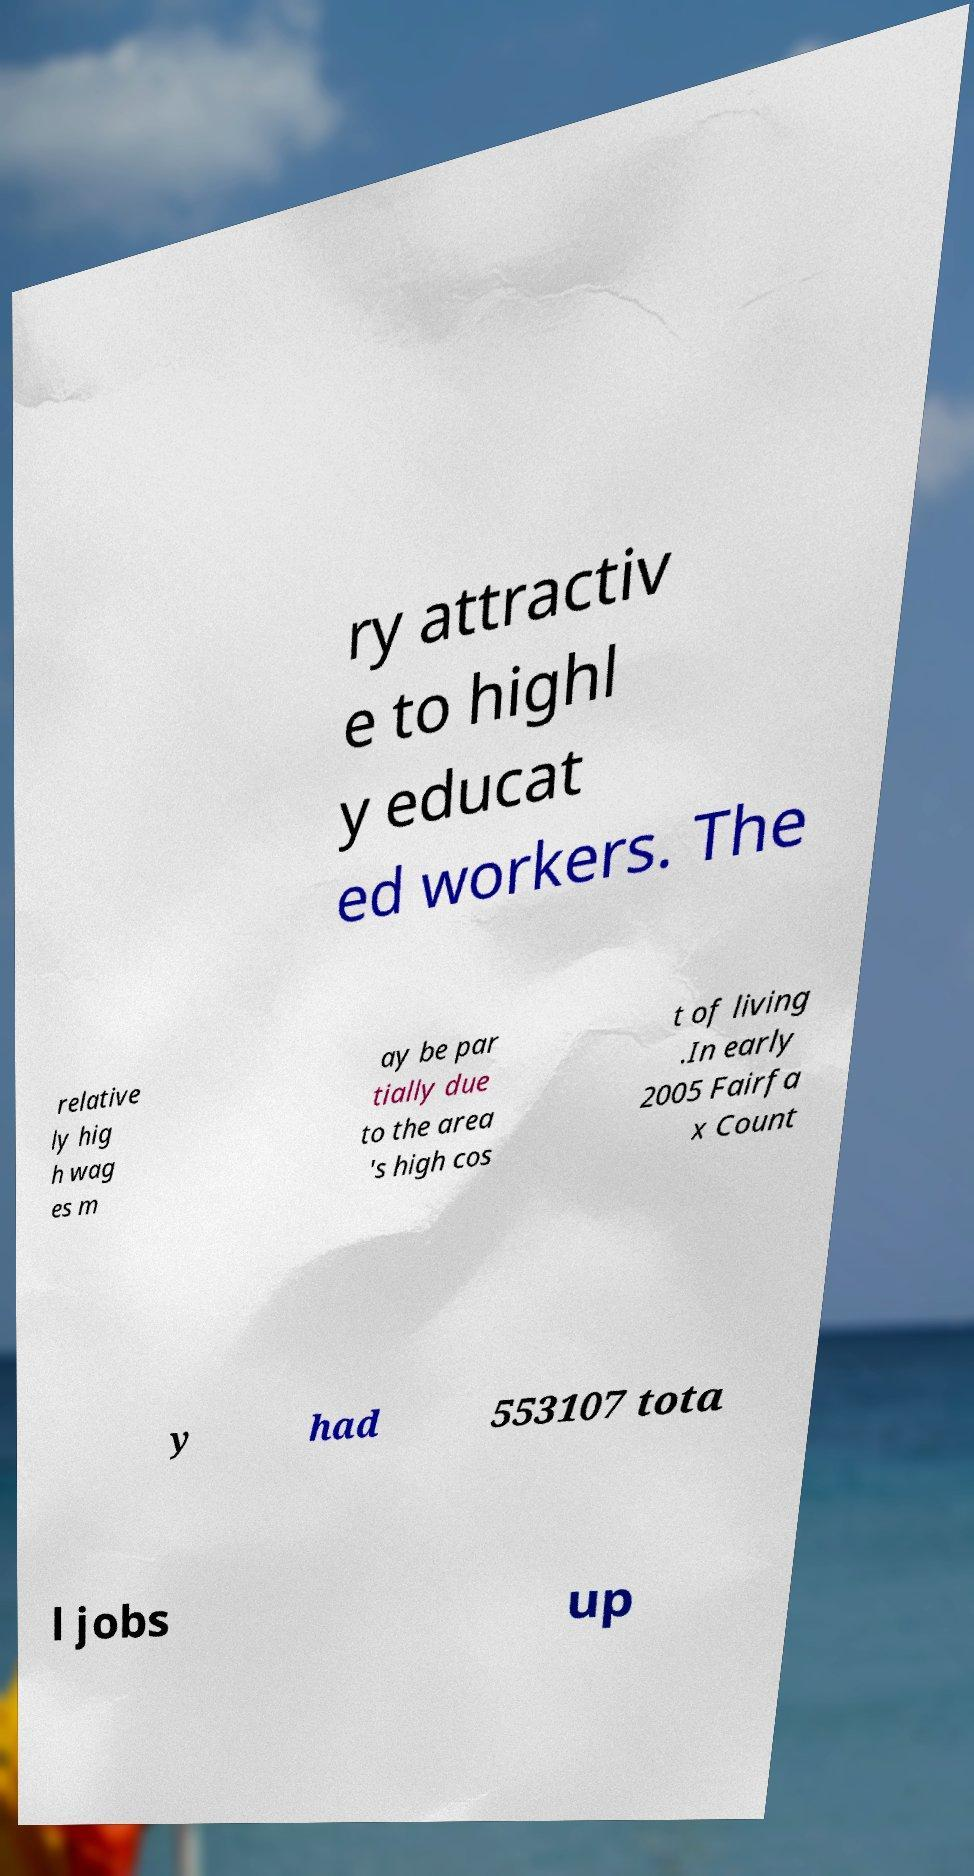What messages or text are displayed in this image? I need them in a readable, typed format. ry attractiv e to highl y educat ed workers. The relative ly hig h wag es m ay be par tially due to the area 's high cos t of living .In early 2005 Fairfa x Count y had 553107 tota l jobs up 